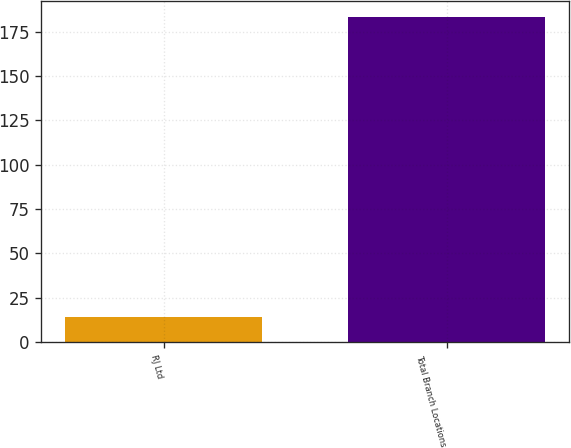Convert chart. <chart><loc_0><loc_0><loc_500><loc_500><bar_chart><fcel>RJ Ltd<fcel>Total Branch Locations<nl><fcel>14<fcel>183<nl></chart> 